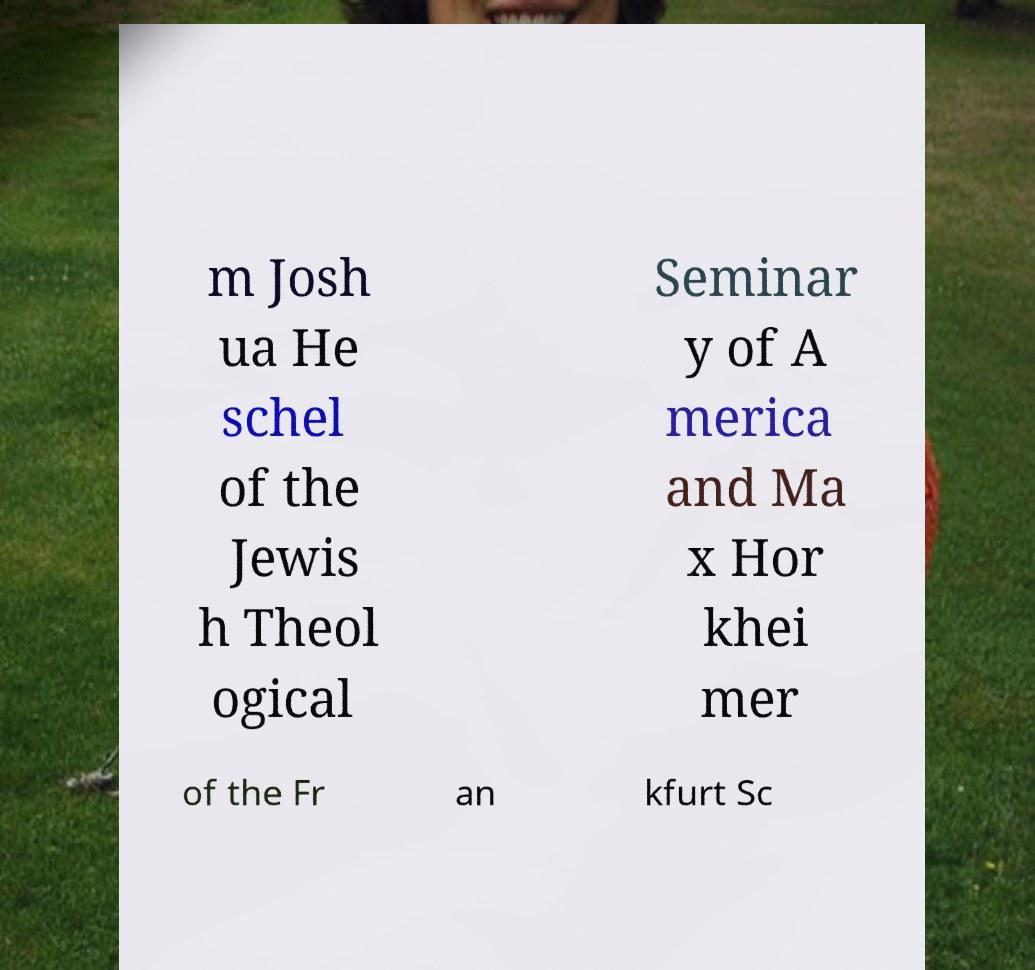Can you read and provide the text displayed in the image?This photo seems to have some interesting text. Can you extract and type it out for me? m Josh ua He schel of the Jewis h Theol ogical Seminar y of A merica and Ma x Hor khei mer of the Fr an kfurt Sc 